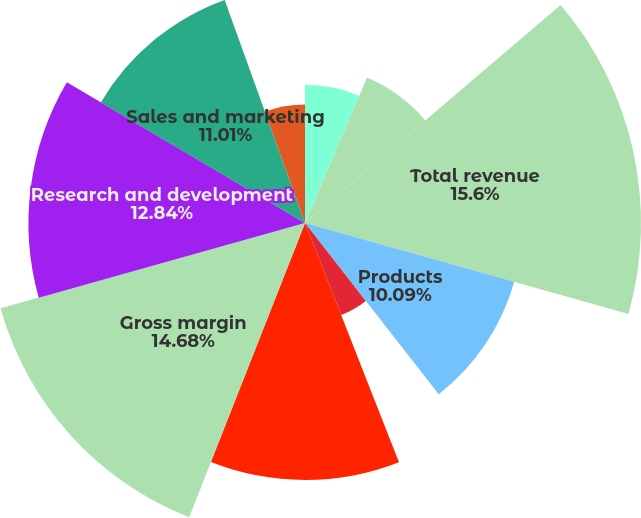Convert chart. <chart><loc_0><loc_0><loc_500><loc_500><pie_chart><fcel>Upfront products<fcel>Maintenance and service<fcel>Total revenue<fcel>Products<fcel>Amortization of intangible<fcel>Total cost of revenue<fcel>Gross margin<fcel>Research and development<fcel>Sales and marketing<fcel>General and administrative<nl><fcel>6.42%<fcel>7.34%<fcel>15.6%<fcel>10.09%<fcel>4.59%<fcel>11.93%<fcel>14.68%<fcel>12.84%<fcel>11.01%<fcel>5.5%<nl></chart> 